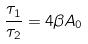Convert formula to latex. <formula><loc_0><loc_0><loc_500><loc_500>\frac { \tau _ { 1 } } { \tau _ { 2 } } = 4 \beta A _ { 0 }</formula> 